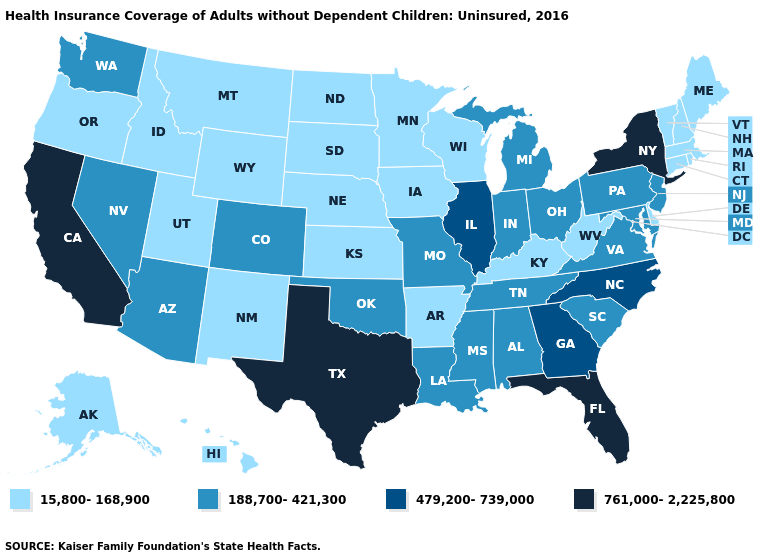What is the value of Connecticut?
Write a very short answer. 15,800-168,900. Is the legend a continuous bar?
Short answer required. No. Does Hawaii have the lowest value in the USA?
Be succinct. Yes. Name the states that have a value in the range 479,200-739,000?
Quick response, please. Georgia, Illinois, North Carolina. What is the value of Alabama?
Give a very brief answer. 188,700-421,300. What is the value of Kansas?
Short answer required. 15,800-168,900. Name the states that have a value in the range 15,800-168,900?
Concise answer only. Alaska, Arkansas, Connecticut, Delaware, Hawaii, Idaho, Iowa, Kansas, Kentucky, Maine, Massachusetts, Minnesota, Montana, Nebraska, New Hampshire, New Mexico, North Dakota, Oregon, Rhode Island, South Dakota, Utah, Vermont, West Virginia, Wisconsin, Wyoming. What is the highest value in states that border Illinois?
Be succinct. 188,700-421,300. Does Indiana have the lowest value in the USA?
Short answer required. No. Does South Carolina have a higher value than Oregon?
Answer briefly. Yes. Name the states that have a value in the range 479,200-739,000?
Quick response, please. Georgia, Illinois, North Carolina. Among the states that border Washington , which have the highest value?
Be succinct. Idaho, Oregon. Among the states that border New Jersey , which have the lowest value?
Write a very short answer. Delaware. Does the first symbol in the legend represent the smallest category?
Give a very brief answer. Yes. 